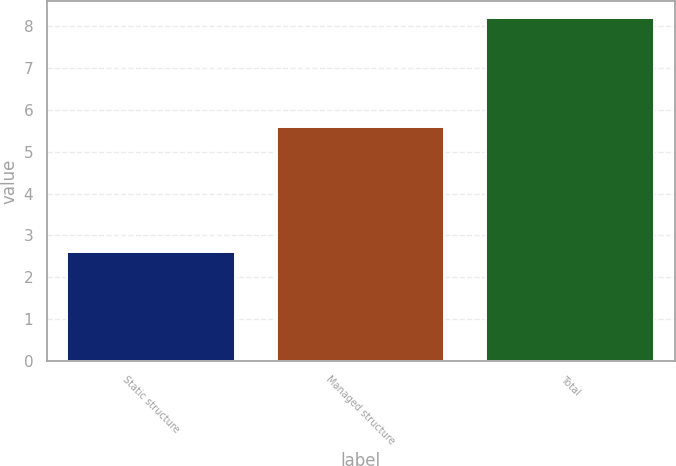Convert chart to OTSL. <chart><loc_0><loc_0><loc_500><loc_500><bar_chart><fcel>Static structure<fcel>Managed structure<fcel>Total<nl><fcel>2.6<fcel>5.6<fcel>8.2<nl></chart> 